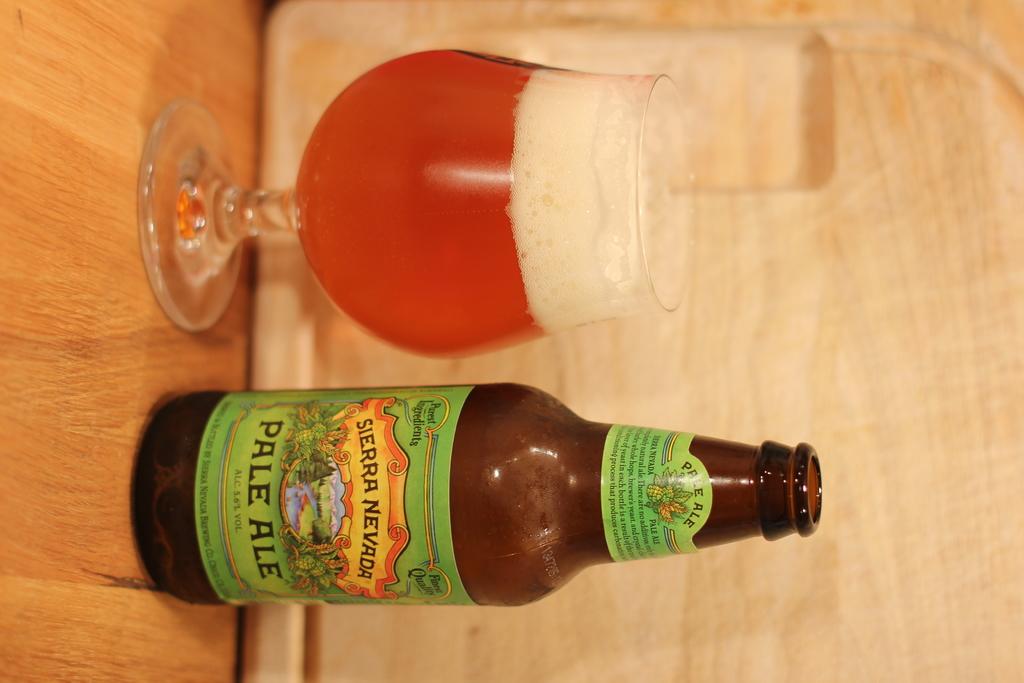What brand of beer?
Provide a succinct answer. Sierra nevada. 